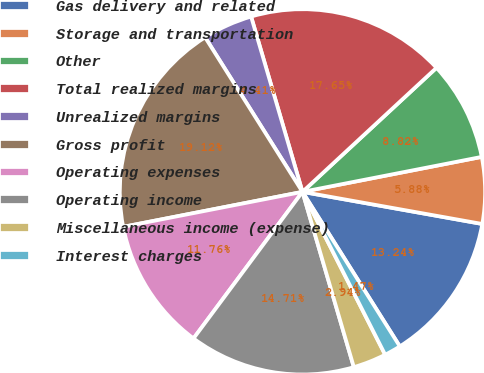<chart> <loc_0><loc_0><loc_500><loc_500><pie_chart><fcel>Gas delivery and related<fcel>Storage and transportation<fcel>Other<fcel>Total realized margins<fcel>Unrealized margins<fcel>Gross profit<fcel>Operating expenses<fcel>Operating income<fcel>Miscellaneous income (expense)<fcel>Interest charges<nl><fcel>13.24%<fcel>5.88%<fcel>8.82%<fcel>17.65%<fcel>4.41%<fcel>19.12%<fcel>11.76%<fcel>14.71%<fcel>2.94%<fcel>1.47%<nl></chart> 